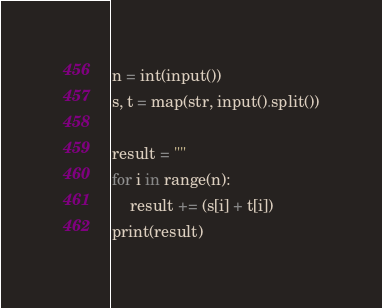<code> <loc_0><loc_0><loc_500><loc_500><_Python_>n = int(input())
s, t = map(str, input().split())

result = ""
for i in range(n):
    result += (s[i] + t[i])
print(result)
</code> 